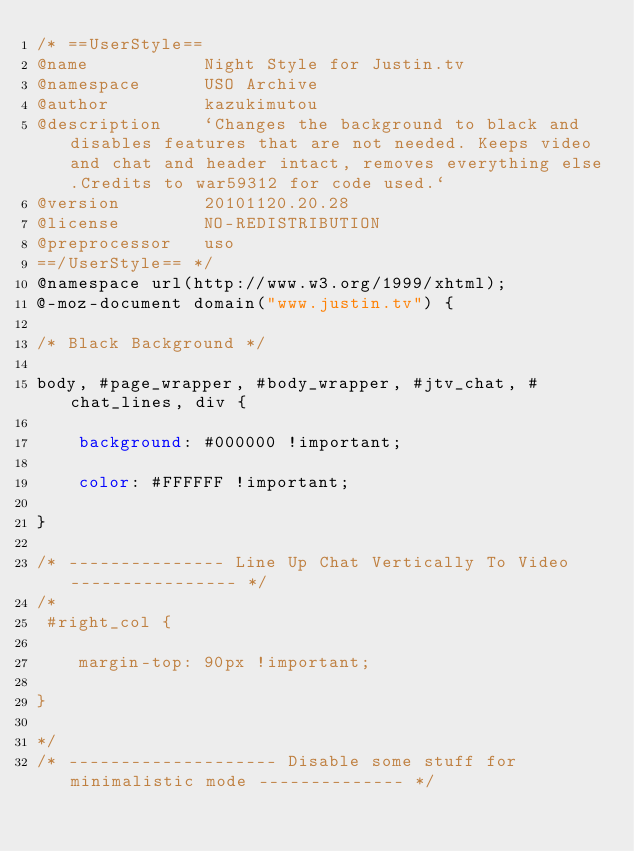<code> <loc_0><loc_0><loc_500><loc_500><_CSS_>/* ==UserStyle==
@name           Night Style for Justin.tv
@namespace      USO Archive
@author         kazukimutou
@description    `Changes the background to black and disables features that are not needed. Keeps video and chat and header intact, removes everything else.Credits to war59312 for code used.`
@version        20101120.20.28
@license        NO-REDISTRIBUTION
@preprocessor   uso
==/UserStyle== */
@namespace url(http://www.w3.org/1999/xhtml);
@-moz-document domain("www.justin.tv") {

/* Black Background */

body, #page_wrapper, #body_wrapper, #jtv_chat, #chat_lines, div {

    background: #000000 !important;

    color: #FFFFFF !important;

}

/* --------------- Line Up Chat Vertically To Video ---------------- */
/*
 #right_col {

    margin-top: 90px !important;

}

*/
/* -------------------- Disable some stuff for minimalistic mode -------------- */</code> 